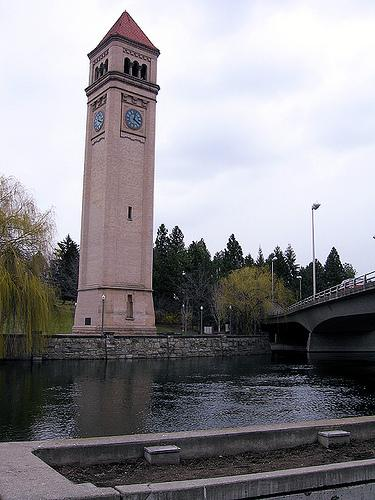What is the clock attached to?

Choices:
A) tower
B) bar stool
C) kitchen wall
D) arena screen tower 